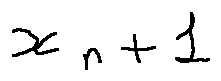<formula> <loc_0><loc_0><loc_500><loc_500>x _ { n + 1 }</formula> 